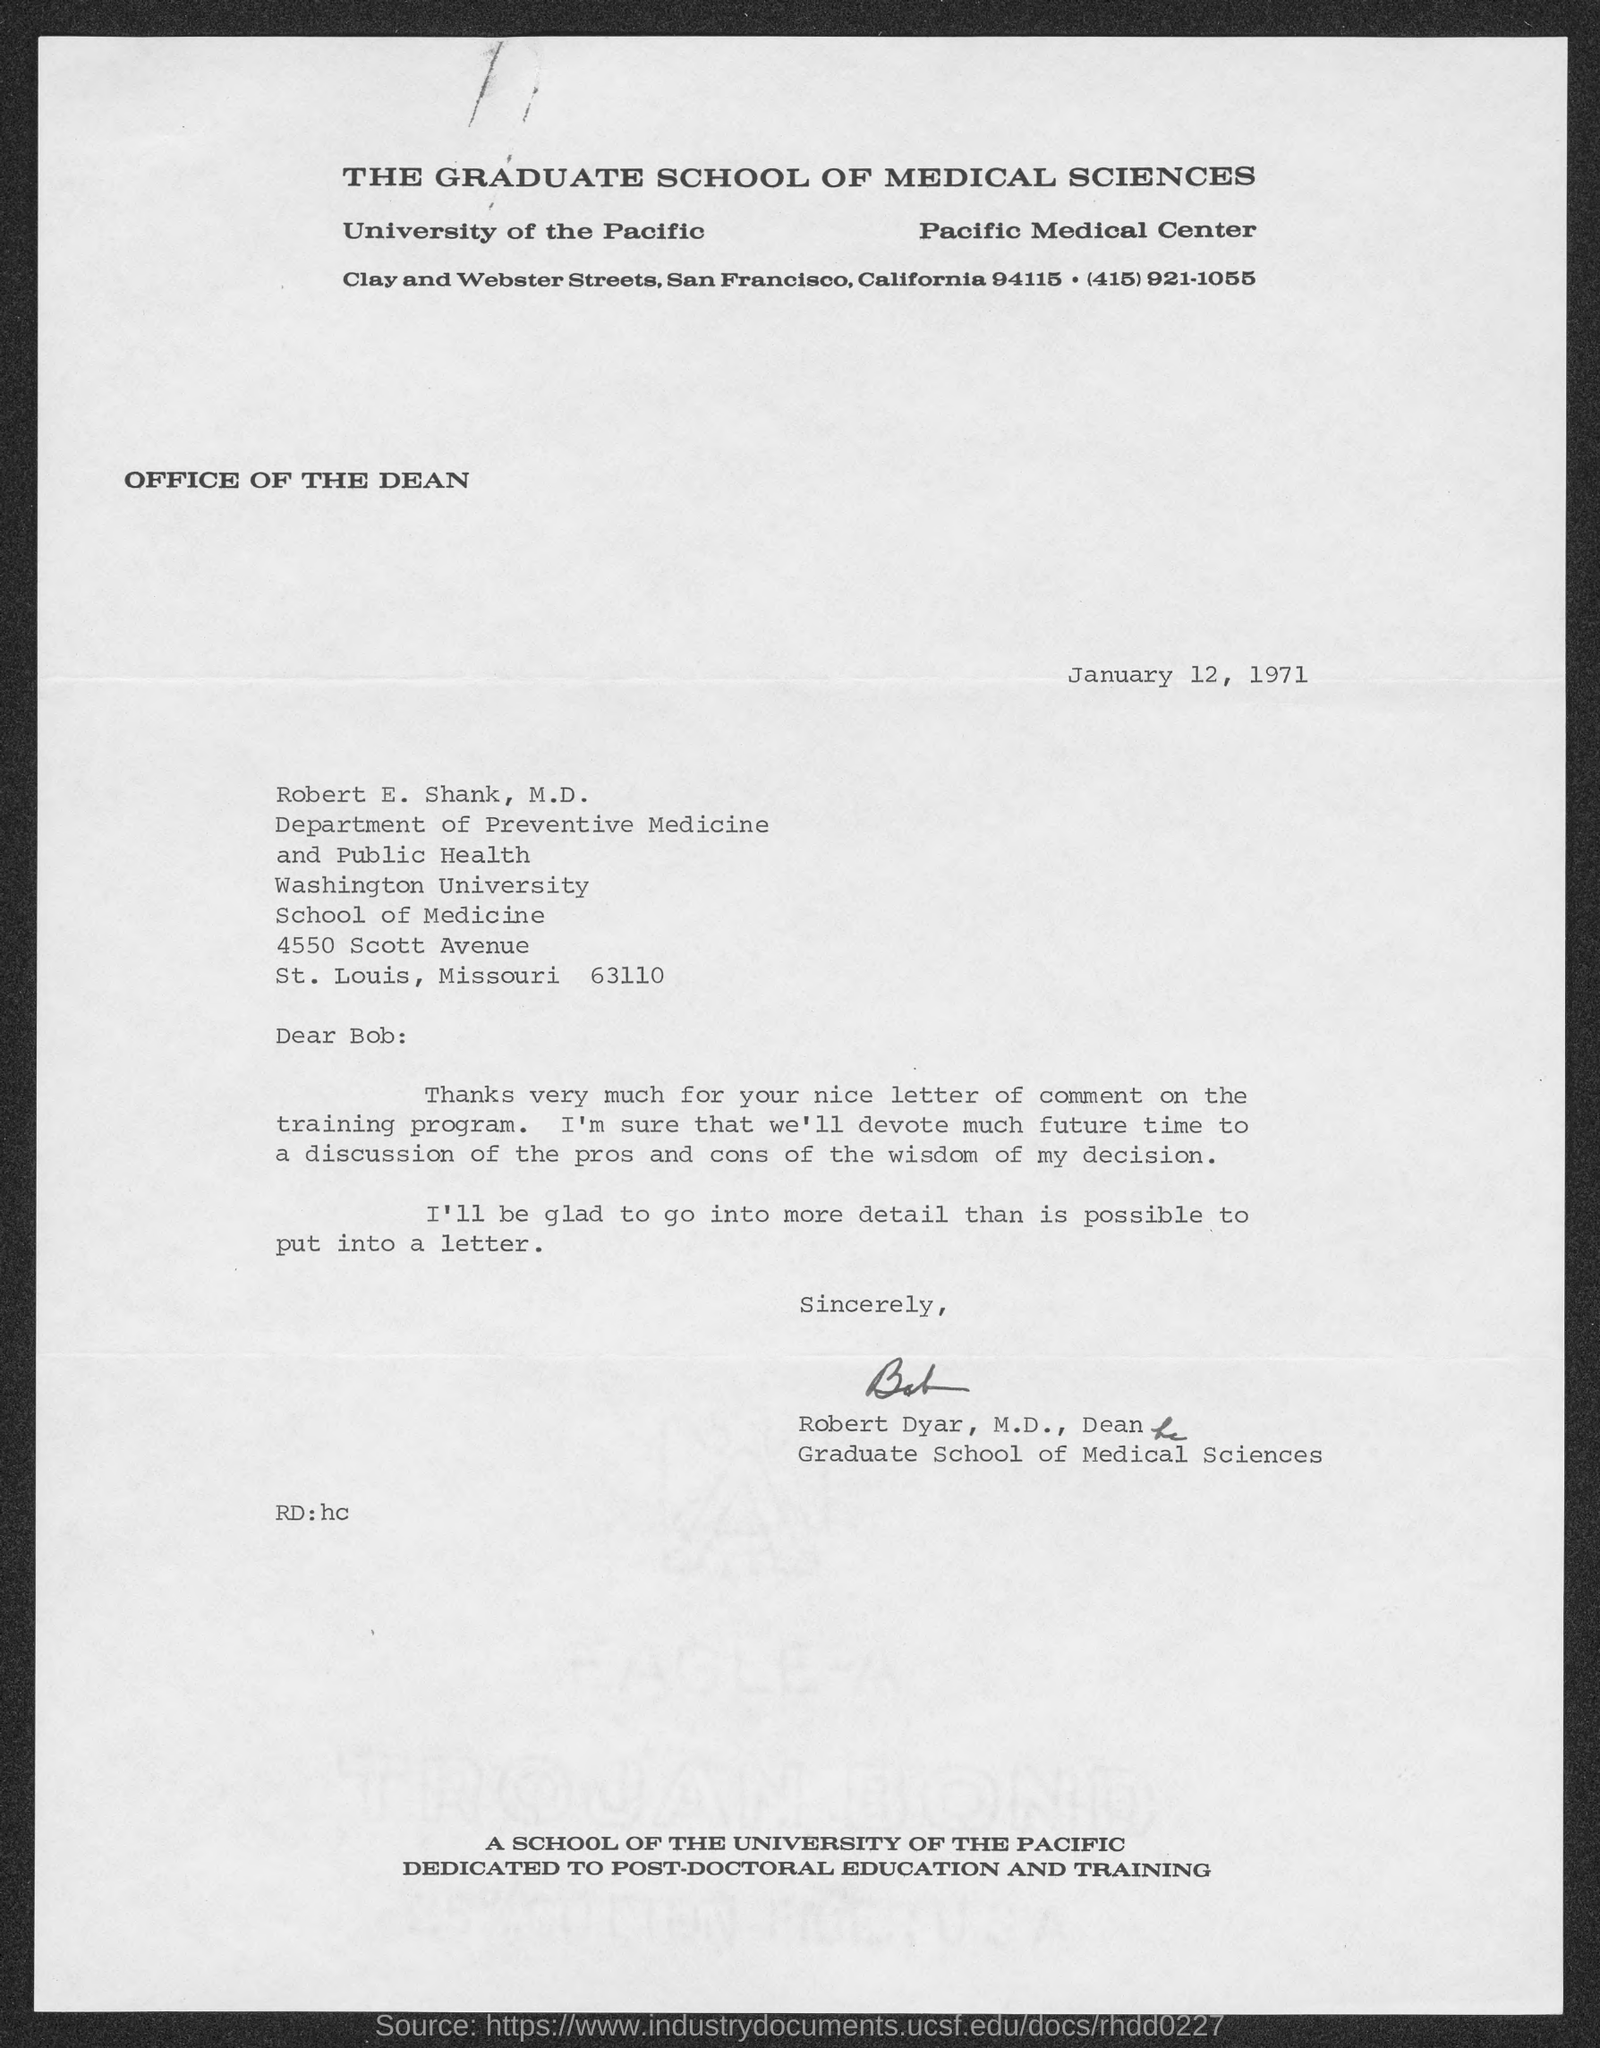What is the date of the letter?
Keep it short and to the point. January 12, 1971. 